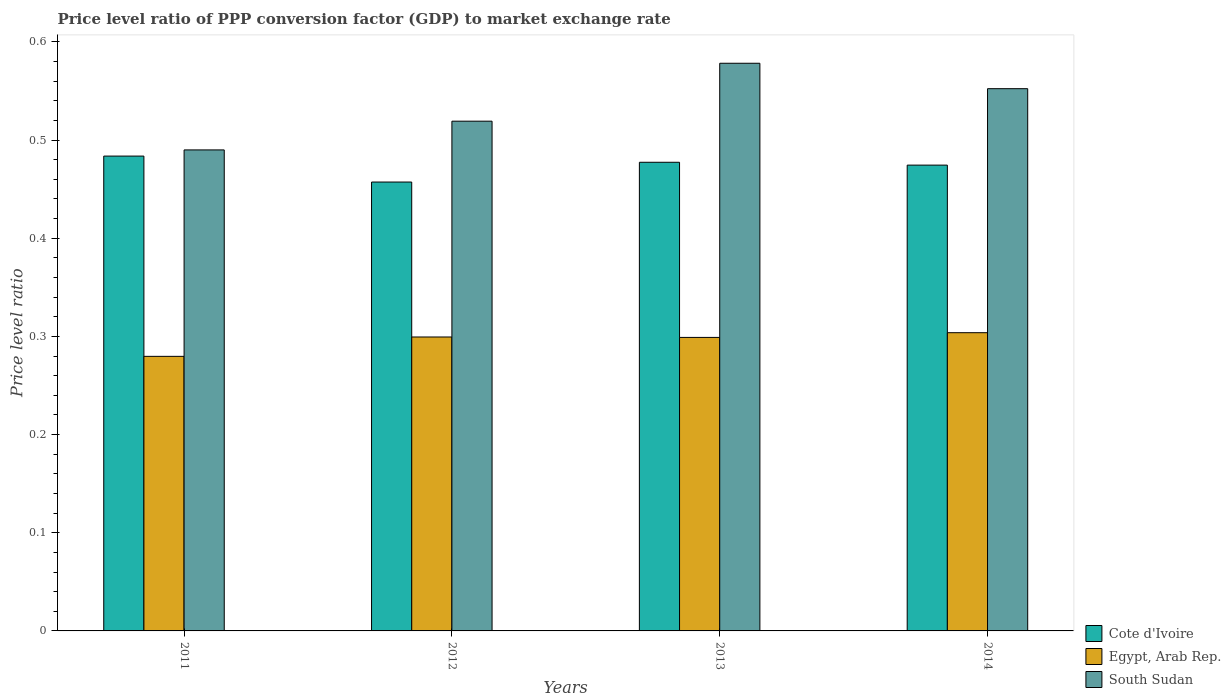Are the number of bars per tick equal to the number of legend labels?
Your answer should be compact. Yes. How many bars are there on the 1st tick from the right?
Your response must be concise. 3. What is the label of the 2nd group of bars from the left?
Ensure brevity in your answer.  2012. What is the price level ratio in South Sudan in 2011?
Give a very brief answer. 0.49. Across all years, what is the maximum price level ratio in Egypt, Arab Rep.?
Offer a very short reply. 0.3. Across all years, what is the minimum price level ratio in Egypt, Arab Rep.?
Give a very brief answer. 0.28. In which year was the price level ratio in South Sudan maximum?
Keep it short and to the point. 2013. What is the total price level ratio in South Sudan in the graph?
Keep it short and to the point. 2.14. What is the difference between the price level ratio in Egypt, Arab Rep. in 2012 and that in 2013?
Ensure brevity in your answer.  0. What is the difference between the price level ratio in South Sudan in 2014 and the price level ratio in Cote d'Ivoire in 2013?
Make the answer very short. 0.07. What is the average price level ratio in Egypt, Arab Rep. per year?
Your answer should be compact. 0.3. In the year 2011, what is the difference between the price level ratio in Cote d'Ivoire and price level ratio in Egypt, Arab Rep.?
Your answer should be compact. 0.2. In how many years, is the price level ratio in South Sudan greater than 0.30000000000000004?
Your answer should be compact. 4. What is the ratio of the price level ratio in South Sudan in 2012 to that in 2014?
Your answer should be very brief. 0.94. Is the price level ratio in Egypt, Arab Rep. in 2011 less than that in 2012?
Ensure brevity in your answer.  Yes. Is the difference between the price level ratio in Cote d'Ivoire in 2011 and 2012 greater than the difference between the price level ratio in Egypt, Arab Rep. in 2011 and 2012?
Make the answer very short. Yes. What is the difference between the highest and the second highest price level ratio in Egypt, Arab Rep.?
Provide a short and direct response. 0. What is the difference between the highest and the lowest price level ratio in South Sudan?
Provide a short and direct response. 0.09. In how many years, is the price level ratio in Cote d'Ivoire greater than the average price level ratio in Cote d'Ivoire taken over all years?
Make the answer very short. 3. What does the 2nd bar from the left in 2011 represents?
Keep it short and to the point. Egypt, Arab Rep. What does the 3rd bar from the right in 2013 represents?
Offer a terse response. Cote d'Ivoire. How many bars are there?
Your response must be concise. 12. Are all the bars in the graph horizontal?
Offer a terse response. No. How many years are there in the graph?
Give a very brief answer. 4. Does the graph contain any zero values?
Ensure brevity in your answer.  No. Does the graph contain grids?
Provide a short and direct response. No. Where does the legend appear in the graph?
Offer a very short reply. Bottom right. How many legend labels are there?
Offer a very short reply. 3. How are the legend labels stacked?
Provide a succinct answer. Vertical. What is the title of the graph?
Offer a very short reply. Price level ratio of PPP conversion factor (GDP) to market exchange rate. Does "Bermuda" appear as one of the legend labels in the graph?
Offer a terse response. No. What is the label or title of the X-axis?
Keep it short and to the point. Years. What is the label or title of the Y-axis?
Offer a terse response. Price level ratio. What is the Price level ratio of Cote d'Ivoire in 2011?
Give a very brief answer. 0.48. What is the Price level ratio of Egypt, Arab Rep. in 2011?
Ensure brevity in your answer.  0.28. What is the Price level ratio of South Sudan in 2011?
Offer a terse response. 0.49. What is the Price level ratio in Cote d'Ivoire in 2012?
Your answer should be very brief. 0.46. What is the Price level ratio of Egypt, Arab Rep. in 2012?
Offer a terse response. 0.3. What is the Price level ratio of South Sudan in 2012?
Your response must be concise. 0.52. What is the Price level ratio in Cote d'Ivoire in 2013?
Keep it short and to the point. 0.48. What is the Price level ratio of Egypt, Arab Rep. in 2013?
Provide a short and direct response. 0.3. What is the Price level ratio in South Sudan in 2013?
Give a very brief answer. 0.58. What is the Price level ratio in Cote d'Ivoire in 2014?
Give a very brief answer. 0.47. What is the Price level ratio of Egypt, Arab Rep. in 2014?
Give a very brief answer. 0.3. What is the Price level ratio in South Sudan in 2014?
Your answer should be compact. 0.55. Across all years, what is the maximum Price level ratio of Cote d'Ivoire?
Your answer should be compact. 0.48. Across all years, what is the maximum Price level ratio of Egypt, Arab Rep.?
Your answer should be compact. 0.3. Across all years, what is the maximum Price level ratio of South Sudan?
Offer a terse response. 0.58. Across all years, what is the minimum Price level ratio in Cote d'Ivoire?
Keep it short and to the point. 0.46. Across all years, what is the minimum Price level ratio in Egypt, Arab Rep.?
Your response must be concise. 0.28. Across all years, what is the minimum Price level ratio in South Sudan?
Offer a very short reply. 0.49. What is the total Price level ratio in Cote d'Ivoire in the graph?
Offer a terse response. 1.89. What is the total Price level ratio of Egypt, Arab Rep. in the graph?
Offer a very short reply. 1.18. What is the total Price level ratio of South Sudan in the graph?
Offer a terse response. 2.14. What is the difference between the Price level ratio of Cote d'Ivoire in 2011 and that in 2012?
Offer a very short reply. 0.03. What is the difference between the Price level ratio of Egypt, Arab Rep. in 2011 and that in 2012?
Offer a terse response. -0.02. What is the difference between the Price level ratio in South Sudan in 2011 and that in 2012?
Your answer should be very brief. -0.03. What is the difference between the Price level ratio of Cote d'Ivoire in 2011 and that in 2013?
Keep it short and to the point. 0.01. What is the difference between the Price level ratio of Egypt, Arab Rep. in 2011 and that in 2013?
Offer a terse response. -0.02. What is the difference between the Price level ratio in South Sudan in 2011 and that in 2013?
Offer a very short reply. -0.09. What is the difference between the Price level ratio of Cote d'Ivoire in 2011 and that in 2014?
Offer a very short reply. 0.01. What is the difference between the Price level ratio of Egypt, Arab Rep. in 2011 and that in 2014?
Offer a very short reply. -0.02. What is the difference between the Price level ratio of South Sudan in 2011 and that in 2014?
Your answer should be compact. -0.06. What is the difference between the Price level ratio of Cote d'Ivoire in 2012 and that in 2013?
Provide a short and direct response. -0.02. What is the difference between the Price level ratio of Egypt, Arab Rep. in 2012 and that in 2013?
Provide a succinct answer. 0. What is the difference between the Price level ratio of South Sudan in 2012 and that in 2013?
Offer a terse response. -0.06. What is the difference between the Price level ratio of Cote d'Ivoire in 2012 and that in 2014?
Give a very brief answer. -0.02. What is the difference between the Price level ratio of Egypt, Arab Rep. in 2012 and that in 2014?
Provide a succinct answer. -0. What is the difference between the Price level ratio of South Sudan in 2012 and that in 2014?
Your answer should be very brief. -0.03. What is the difference between the Price level ratio in Cote d'Ivoire in 2013 and that in 2014?
Your answer should be compact. 0. What is the difference between the Price level ratio in Egypt, Arab Rep. in 2013 and that in 2014?
Your answer should be compact. -0. What is the difference between the Price level ratio in South Sudan in 2013 and that in 2014?
Offer a terse response. 0.03. What is the difference between the Price level ratio of Cote d'Ivoire in 2011 and the Price level ratio of Egypt, Arab Rep. in 2012?
Your response must be concise. 0.18. What is the difference between the Price level ratio in Cote d'Ivoire in 2011 and the Price level ratio in South Sudan in 2012?
Your answer should be very brief. -0.04. What is the difference between the Price level ratio in Egypt, Arab Rep. in 2011 and the Price level ratio in South Sudan in 2012?
Your answer should be very brief. -0.24. What is the difference between the Price level ratio in Cote d'Ivoire in 2011 and the Price level ratio in Egypt, Arab Rep. in 2013?
Your answer should be compact. 0.18. What is the difference between the Price level ratio in Cote d'Ivoire in 2011 and the Price level ratio in South Sudan in 2013?
Offer a terse response. -0.09. What is the difference between the Price level ratio in Egypt, Arab Rep. in 2011 and the Price level ratio in South Sudan in 2013?
Your answer should be compact. -0.3. What is the difference between the Price level ratio of Cote d'Ivoire in 2011 and the Price level ratio of Egypt, Arab Rep. in 2014?
Give a very brief answer. 0.18. What is the difference between the Price level ratio of Cote d'Ivoire in 2011 and the Price level ratio of South Sudan in 2014?
Ensure brevity in your answer.  -0.07. What is the difference between the Price level ratio of Egypt, Arab Rep. in 2011 and the Price level ratio of South Sudan in 2014?
Ensure brevity in your answer.  -0.27. What is the difference between the Price level ratio in Cote d'Ivoire in 2012 and the Price level ratio in Egypt, Arab Rep. in 2013?
Your response must be concise. 0.16. What is the difference between the Price level ratio in Cote d'Ivoire in 2012 and the Price level ratio in South Sudan in 2013?
Make the answer very short. -0.12. What is the difference between the Price level ratio of Egypt, Arab Rep. in 2012 and the Price level ratio of South Sudan in 2013?
Give a very brief answer. -0.28. What is the difference between the Price level ratio of Cote d'Ivoire in 2012 and the Price level ratio of Egypt, Arab Rep. in 2014?
Your answer should be compact. 0.15. What is the difference between the Price level ratio in Cote d'Ivoire in 2012 and the Price level ratio in South Sudan in 2014?
Ensure brevity in your answer.  -0.1. What is the difference between the Price level ratio in Egypt, Arab Rep. in 2012 and the Price level ratio in South Sudan in 2014?
Provide a short and direct response. -0.25. What is the difference between the Price level ratio in Cote d'Ivoire in 2013 and the Price level ratio in Egypt, Arab Rep. in 2014?
Make the answer very short. 0.17. What is the difference between the Price level ratio in Cote d'Ivoire in 2013 and the Price level ratio in South Sudan in 2014?
Keep it short and to the point. -0.07. What is the difference between the Price level ratio of Egypt, Arab Rep. in 2013 and the Price level ratio of South Sudan in 2014?
Your answer should be compact. -0.25. What is the average Price level ratio of Cote d'Ivoire per year?
Ensure brevity in your answer.  0.47. What is the average Price level ratio in Egypt, Arab Rep. per year?
Ensure brevity in your answer.  0.3. What is the average Price level ratio of South Sudan per year?
Offer a terse response. 0.53. In the year 2011, what is the difference between the Price level ratio in Cote d'Ivoire and Price level ratio in Egypt, Arab Rep.?
Keep it short and to the point. 0.2. In the year 2011, what is the difference between the Price level ratio of Cote d'Ivoire and Price level ratio of South Sudan?
Offer a terse response. -0.01. In the year 2011, what is the difference between the Price level ratio of Egypt, Arab Rep. and Price level ratio of South Sudan?
Ensure brevity in your answer.  -0.21. In the year 2012, what is the difference between the Price level ratio in Cote d'Ivoire and Price level ratio in Egypt, Arab Rep.?
Your answer should be compact. 0.16. In the year 2012, what is the difference between the Price level ratio in Cote d'Ivoire and Price level ratio in South Sudan?
Make the answer very short. -0.06. In the year 2012, what is the difference between the Price level ratio in Egypt, Arab Rep. and Price level ratio in South Sudan?
Your answer should be compact. -0.22. In the year 2013, what is the difference between the Price level ratio in Cote d'Ivoire and Price level ratio in Egypt, Arab Rep.?
Offer a terse response. 0.18. In the year 2013, what is the difference between the Price level ratio in Cote d'Ivoire and Price level ratio in South Sudan?
Provide a succinct answer. -0.1. In the year 2013, what is the difference between the Price level ratio of Egypt, Arab Rep. and Price level ratio of South Sudan?
Provide a short and direct response. -0.28. In the year 2014, what is the difference between the Price level ratio of Cote d'Ivoire and Price level ratio of Egypt, Arab Rep.?
Keep it short and to the point. 0.17. In the year 2014, what is the difference between the Price level ratio in Cote d'Ivoire and Price level ratio in South Sudan?
Your answer should be compact. -0.08. In the year 2014, what is the difference between the Price level ratio of Egypt, Arab Rep. and Price level ratio of South Sudan?
Offer a terse response. -0.25. What is the ratio of the Price level ratio of Cote d'Ivoire in 2011 to that in 2012?
Provide a succinct answer. 1.06. What is the ratio of the Price level ratio in Egypt, Arab Rep. in 2011 to that in 2012?
Provide a succinct answer. 0.93. What is the ratio of the Price level ratio of South Sudan in 2011 to that in 2012?
Your answer should be very brief. 0.94. What is the ratio of the Price level ratio in Cote d'Ivoire in 2011 to that in 2013?
Provide a succinct answer. 1.01. What is the ratio of the Price level ratio of Egypt, Arab Rep. in 2011 to that in 2013?
Provide a short and direct response. 0.94. What is the ratio of the Price level ratio in South Sudan in 2011 to that in 2013?
Provide a succinct answer. 0.85. What is the ratio of the Price level ratio of Cote d'Ivoire in 2011 to that in 2014?
Provide a succinct answer. 1.02. What is the ratio of the Price level ratio in Egypt, Arab Rep. in 2011 to that in 2014?
Provide a succinct answer. 0.92. What is the ratio of the Price level ratio of South Sudan in 2011 to that in 2014?
Your response must be concise. 0.89. What is the ratio of the Price level ratio of Cote d'Ivoire in 2012 to that in 2013?
Offer a terse response. 0.96. What is the ratio of the Price level ratio of South Sudan in 2012 to that in 2013?
Offer a very short reply. 0.9. What is the ratio of the Price level ratio of Cote d'Ivoire in 2012 to that in 2014?
Provide a short and direct response. 0.96. What is the ratio of the Price level ratio in Egypt, Arab Rep. in 2012 to that in 2014?
Provide a succinct answer. 0.99. What is the ratio of the Price level ratio in South Sudan in 2012 to that in 2014?
Your response must be concise. 0.94. What is the ratio of the Price level ratio in Cote d'Ivoire in 2013 to that in 2014?
Your answer should be very brief. 1.01. What is the ratio of the Price level ratio in Egypt, Arab Rep. in 2013 to that in 2014?
Offer a terse response. 0.98. What is the ratio of the Price level ratio of South Sudan in 2013 to that in 2014?
Offer a very short reply. 1.05. What is the difference between the highest and the second highest Price level ratio in Cote d'Ivoire?
Your response must be concise. 0.01. What is the difference between the highest and the second highest Price level ratio in Egypt, Arab Rep.?
Offer a very short reply. 0. What is the difference between the highest and the second highest Price level ratio of South Sudan?
Give a very brief answer. 0.03. What is the difference between the highest and the lowest Price level ratio of Cote d'Ivoire?
Provide a short and direct response. 0.03. What is the difference between the highest and the lowest Price level ratio of Egypt, Arab Rep.?
Provide a succinct answer. 0.02. What is the difference between the highest and the lowest Price level ratio in South Sudan?
Make the answer very short. 0.09. 